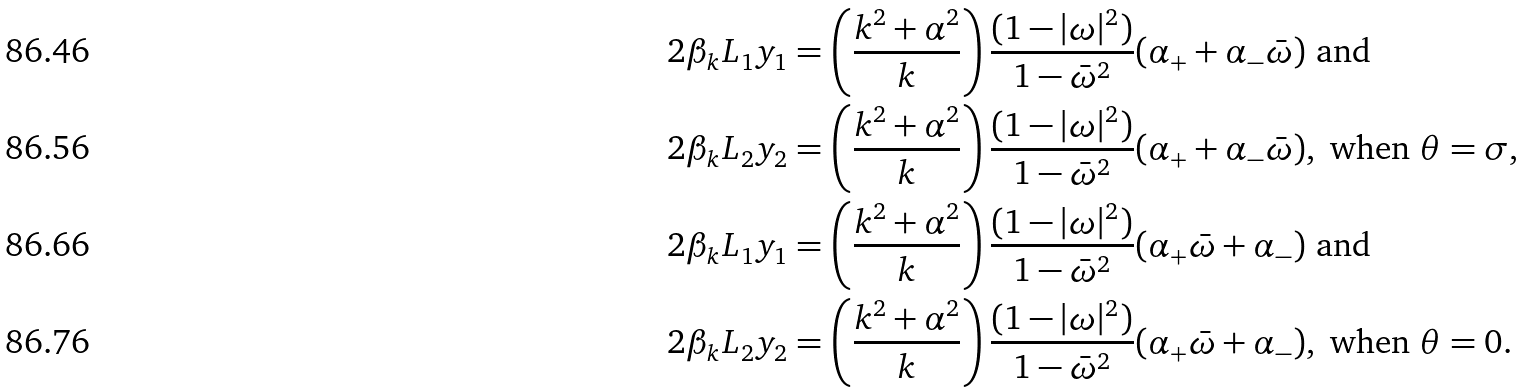Convert formula to latex. <formula><loc_0><loc_0><loc_500><loc_500>& 2 \beta _ { k } L _ { 1 } y _ { 1 } = \left ( \frac { k ^ { 2 } + \alpha ^ { 2 } } { k } \right ) \frac { ( 1 - | \omega | ^ { 2 } ) } { 1 - { \bar { \omega } } ^ { 2 } } ( \alpha _ { + } + { \alpha } _ { - } \bar { \omega } ) \text { and } \\ & 2 \beta _ { k } L _ { 2 } y _ { 2 } = \left ( \frac { k ^ { 2 } + \alpha ^ { 2 } } { k } \right ) \frac { ( 1 - | \omega | ^ { 2 } ) } { 1 - { \bar { \omega } } ^ { 2 } } ( \alpha _ { + } + { \alpha } _ { - } \bar { \omega } ) , \text { when } \theta = \sigma , \\ & 2 \beta _ { k } L _ { 1 } y _ { 1 } = \left ( \frac { k ^ { 2 } + \alpha ^ { 2 } } { k } \right ) \frac { ( 1 - | \omega | ^ { 2 } ) } { 1 - { \bar { \omega } } ^ { 2 } } ( \alpha _ { + } \bar { \omega } + { \alpha } _ { - } ) \text { and } \\ & 2 \beta _ { k } L _ { 2 } y _ { 2 } = \left ( \frac { k ^ { 2 } + \alpha ^ { 2 } } { k } \right ) \frac { ( 1 - | \omega | ^ { 2 } ) } { 1 - { \bar { \omega } } ^ { 2 } } ( \alpha _ { + } \bar { \omega } + { \alpha } _ { - } ) , \text { when } \theta = 0 .</formula> 